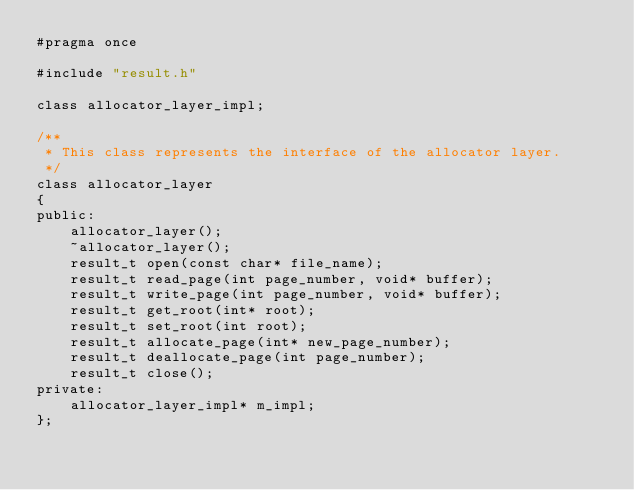Convert code to text. <code><loc_0><loc_0><loc_500><loc_500><_C_>#pragma once

#include "result.h"

class allocator_layer_impl;

/**
 * This class represents the interface of the allocator layer.
 */
class allocator_layer
{
public:
    allocator_layer();
    ~allocator_layer();
    result_t open(const char* file_name);
    result_t read_page(int page_number, void* buffer);
    result_t write_page(int page_number, void* buffer);
    result_t get_root(int* root);
    result_t set_root(int root);
    result_t allocate_page(int* new_page_number);
    result_t deallocate_page(int page_number);
    result_t close();
private:
    allocator_layer_impl* m_impl;
};
</code> 